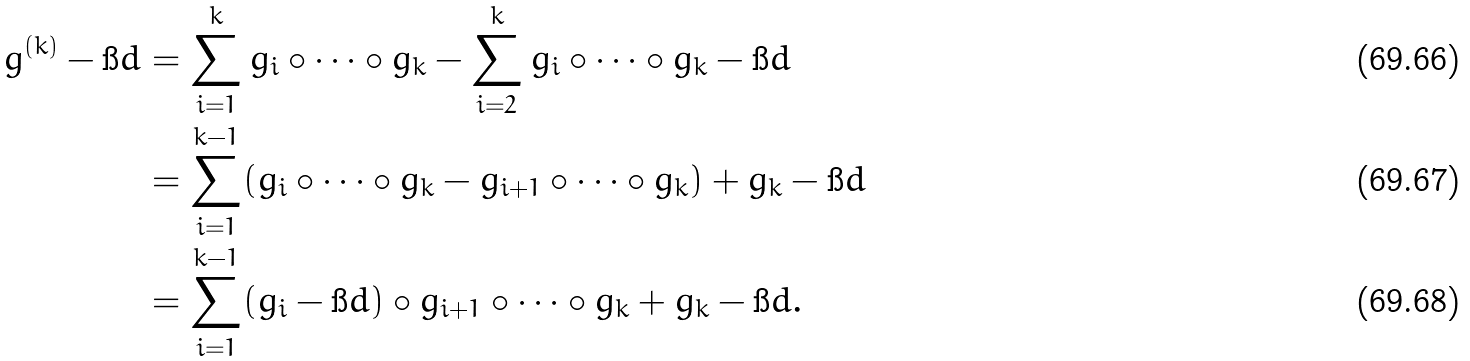<formula> <loc_0><loc_0><loc_500><loc_500>g ^ { ( k ) } - \i d & = \sum _ { i = 1 } ^ { k } g _ { i } \circ \cdots \circ g _ { k } - \sum _ { i = 2 } ^ { k } g _ { i } \circ \cdots \circ g _ { k } - \i d \\ & = \sum _ { i = 1 } ^ { k - 1 } ( g _ { i } \circ \cdots \circ g _ { k } - g _ { i + 1 } \circ \cdots \circ g _ { k } ) + g _ { k } - \i d \\ & = \sum _ { i = 1 } ^ { k - 1 } ( g _ { i } - \i d ) \circ g _ { i + 1 } \circ \cdots \circ g _ { k } + g _ { k } - \i d .</formula> 